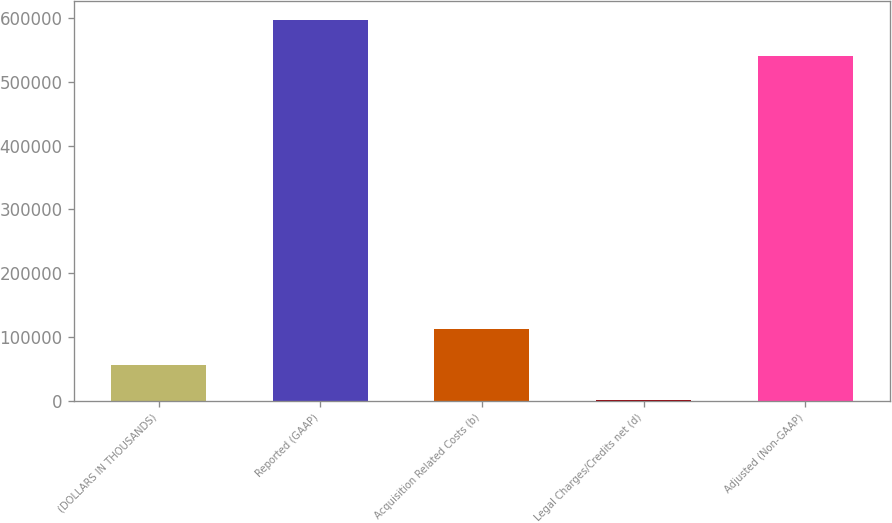<chart> <loc_0><loc_0><loc_500><loc_500><bar_chart><fcel>(DOLLARS IN THOUSANDS)<fcel>Reported (GAAP)<fcel>Acquisition Related Costs (b)<fcel>Legal Charges/Credits net (d)<fcel>Adjusted (Non-GAAP)<nl><fcel>56631.1<fcel>596942<fcel>112262<fcel>1000<fcel>541311<nl></chart> 